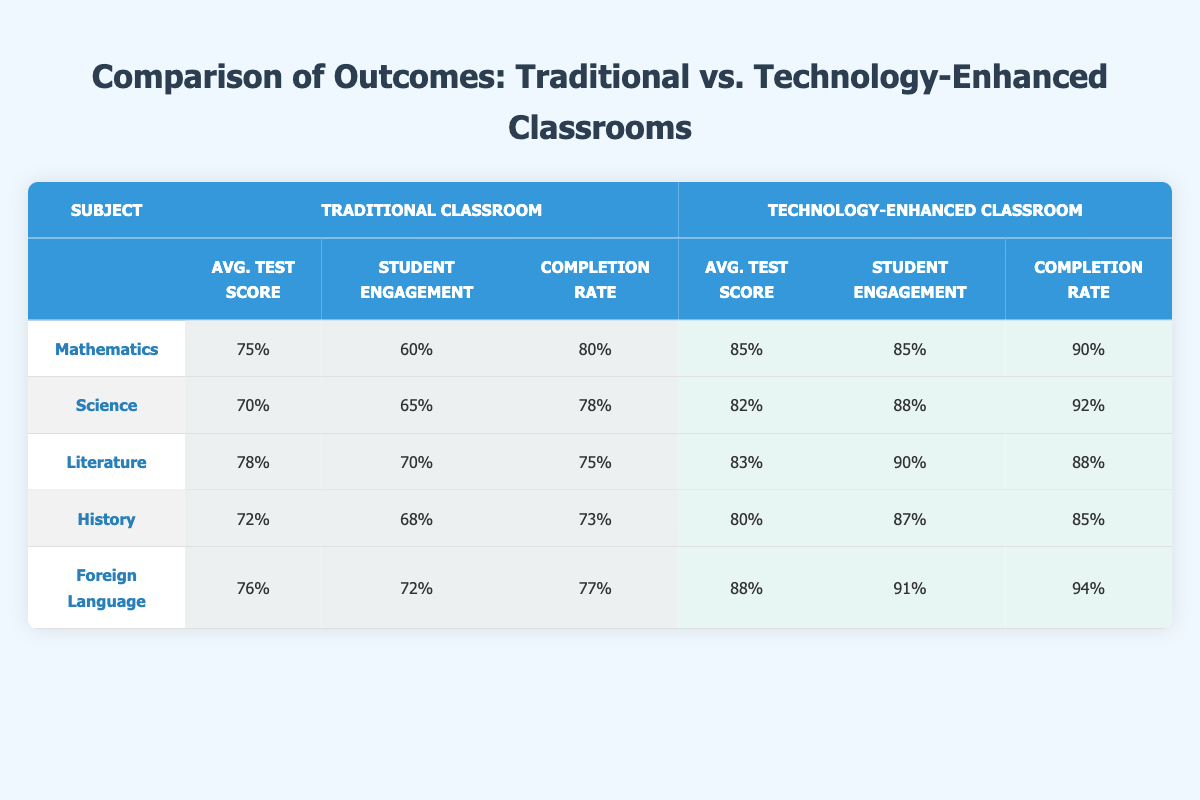What is the average test score in Mathematics for the technology-enhanced classroom? The average test score for the technology-enhanced classroom in Mathematics is clearly shown in the table as 85%.
Answer: 85% What is the completion rate for Literature in the traditional classroom? The table presents the completion rate for Literature in the traditional classroom as 75%.
Answer: 75% Did student engagement in the technology-enhanced classroom exceed 90% in any subject? Looking at the table, the engagement rate for the technology-enhanced classroom in Foreign Language is 91%, which exceeds 90%.
Answer: Yes What is the difference in average test scores between traditional and technology-enhanced classrooms in Science? The average test score for traditional classrooms in Science is 70% and for technology-enhanced classrooms is 82%. The difference is 82% - 70% = 12%.
Answer: 12% Which subject has the highest completion rate in a technology-enhanced classroom? In the table, the completion rates for the technology-enhanced classroom are: Mathematics (90%), Science (92%), Literature (88%), History (85%), and Foreign Language (94%). Foreign Language has the highest completion rate at 94%.
Answer: Foreign Language What is the average student engagement rate across all subjects for the traditional classrooms? The student engagement rates for traditional classrooms are: Mathematics (60%), Science (65%), Literature (70%), History (68%), and Foreign Language (72%). To find the average, we sum these rates: 60 + 65 + 70 + 68 + 72 = 335. Dividing by 5 gives 335 / 5 = 67%.
Answer: 67% Is the average test score in the traditional classroom for History higher than in Mathematics? In the table, the average test score for History is 72% and for Mathematics is 75%. Since 75% is greater than 72%, the statement is false.
Answer: No What percentage increase in average test score does Foreign Language show from traditional to technology-enhanced classrooms? The average test score for traditional Foreign Language classrooms is 76% and for technology-enhanced classrooms is 88%. The increase is calculated as (88% - 76%) / 76% * 100 = 15.79%, which rounds up to approximately 16%.
Answer: 16% In which classroom setting (traditional or technology-enhanced) did students perform better in Science? By comparing the average test scores in Science, traditional classrooms scored 70% while technology-enhanced classrooms scored 82%. Since 82% is higher, students performed better in the technology-enhanced classroom.
Answer: Technology-enhanced classroom 